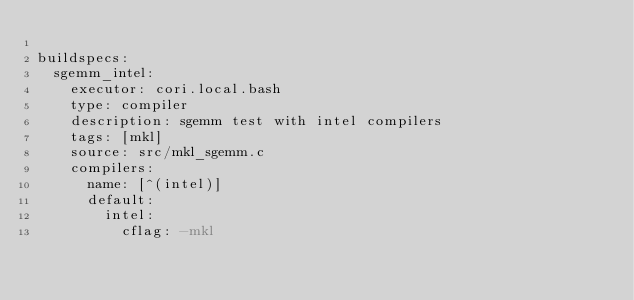Convert code to text. <code><loc_0><loc_0><loc_500><loc_500><_YAML_>
buildspecs:
  sgemm_intel:
    executor: cori.local.bash
    type: compiler
    description: sgemm test with intel compilers
    tags: [mkl]
    source: src/mkl_sgemm.c
    compilers:
      name: [^(intel)]
      default:
        intel:
          cflag: -mkl
</code> 